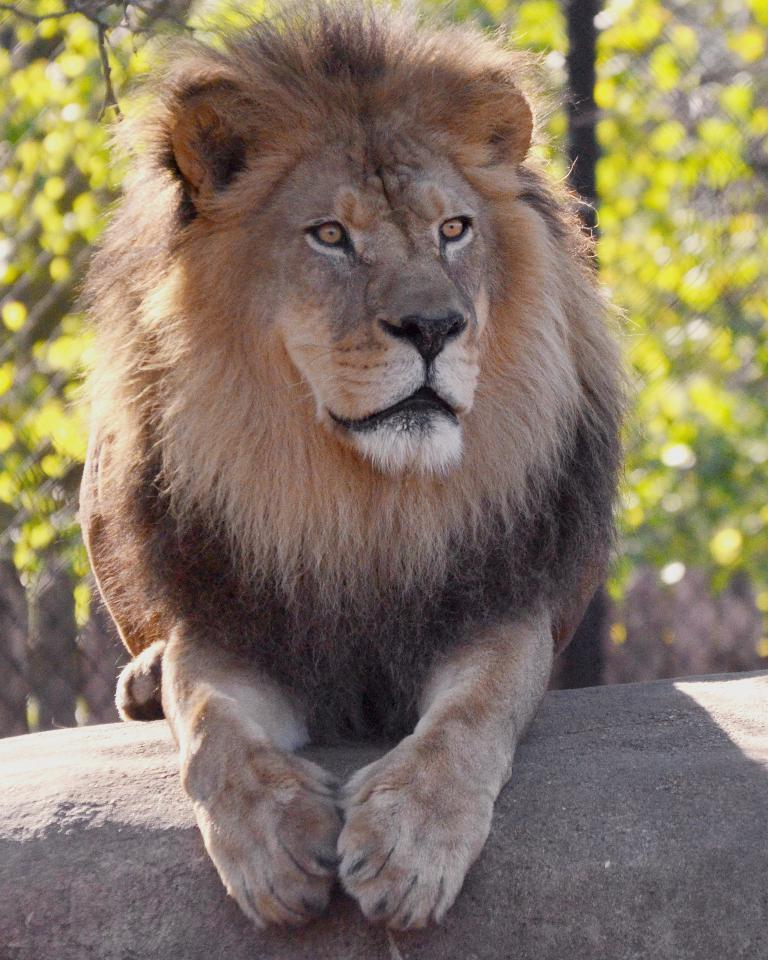What animal is present in the image? There is a lion in the image. What can be seen in the background of the image? There are trees in the background of the image. How many beds can be seen in the image? There are no beds present in the image. What type of train is visible in the image? There is no train present in the image. 